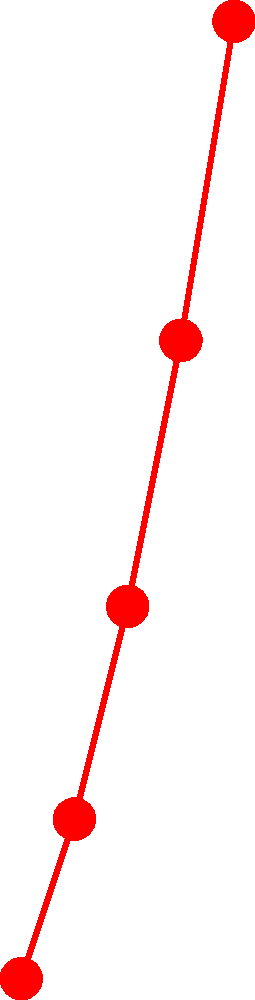Based on the infographic showing private aviation industry trends, what is the projected market share for your disruptive private jet booking app in 2024, and what is the corresponding growth rate for that year? To answer this question, we need to analyze the trends shown in the infographic:

1. The red line with circular markers represents the market share (%).
2. The blue line with cross markers represents the growth rate (%).
3. The x-axis shows the years from 2020 to 2024.

Looking at the year 2024:

1. For market share:
   - Follow the red line to the rightmost point (2024).
   - The y-axis value for this point is 33%.

2. For growth rate:
   - Follow the blue line to the rightmost point (2024).
   - The y-axis value for this point is 25%.

Therefore, in 2024:
- The projected market share is 33%.
- The corresponding growth rate is 25%.
Answer: 33% market share, 25% growth rate 